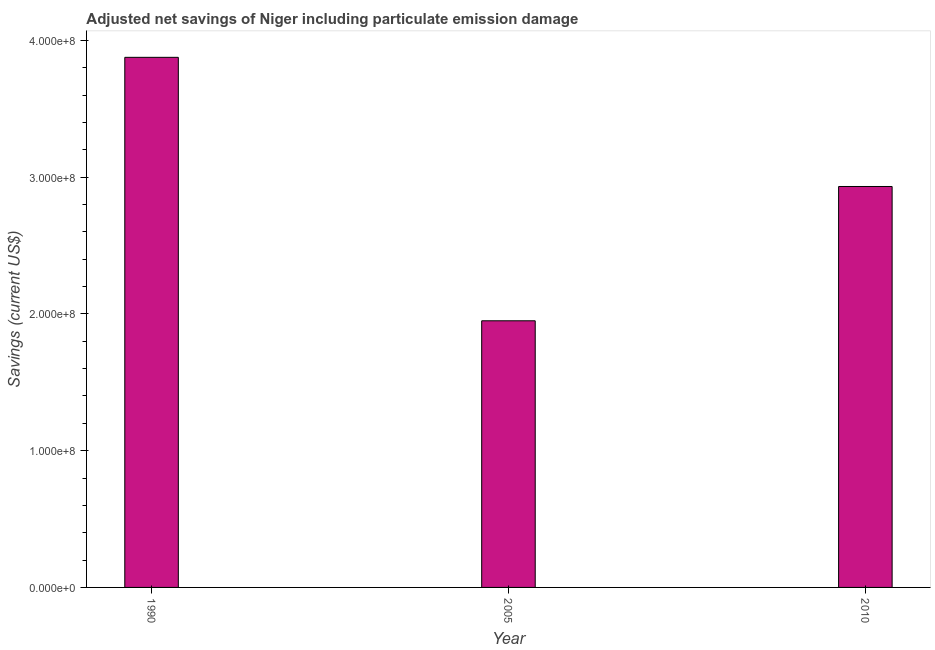What is the title of the graph?
Ensure brevity in your answer.  Adjusted net savings of Niger including particulate emission damage. What is the label or title of the Y-axis?
Give a very brief answer. Savings (current US$). What is the adjusted net savings in 2005?
Provide a short and direct response. 1.95e+08. Across all years, what is the maximum adjusted net savings?
Your response must be concise. 3.88e+08. Across all years, what is the minimum adjusted net savings?
Your answer should be compact. 1.95e+08. In which year was the adjusted net savings minimum?
Provide a succinct answer. 2005. What is the sum of the adjusted net savings?
Keep it short and to the point. 8.76e+08. What is the difference between the adjusted net savings in 1990 and 2005?
Your answer should be compact. 1.93e+08. What is the average adjusted net savings per year?
Your answer should be very brief. 2.92e+08. What is the median adjusted net savings?
Give a very brief answer. 2.93e+08. Do a majority of the years between 2010 and 2005 (inclusive) have adjusted net savings greater than 100000000 US$?
Your answer should be compact. No. What is the ratio of the adjusted net savings in 1990 to that in 2010?
Provide a succinct answer. 1.32. What is the difference between the highest and the second highest adjusted net savings?
Make the answer very short. 9.45e+07. What is the difference between the highest and the lowest adjusted net savings?
Your response must be concise. 1.93e+08. In how many years, is the adjusted net savings greater than the average adjusted net savings taken over all years?
Make the answer very short. 2. Are all the bars in the graph horizontal?
Offer a very short reply. No. What is the difference between two consecutive major ticks on the Y-axis?
Keep it short and to the point. 1.00e+08. Are the values on the major ticks of Y-axis written in scientific E-notation?
Your answer should be compact. Yes. What is the Savings (current US$) in 1990?
Provide a short and direct response. 3.88e+08. What is the Savings (current US$) of 2005?
Your answer should be very brief. 1.95e+08. What is the Savings (current US$) in 2010?
Offer a very short reply. 2.93e+08. What is the difference between the Savings (current US$) in 1990 and 2005?
Ensure brevity in your answer.  1.93e+08. What is the difference between the Savings (current US$) in 1990 and 2010?
Keep it short and to the point. 9.45e+07. What is the difference between the Savings (current US$) in 2005 and 2010?
Provide a succinct answer. -9.82e+07. What is the ratio of the Savings (current US$) in 1990 to that in 2005?
Your response must be concise. 1.99. What is the ratio of the Savings (current US$) in 1990 to that in 2010?
Your answer should be compact. 1.32. What is the ratio of the Savings (current US$) in 2005 to that in 2010?
Your response must be concise. 0.67. 